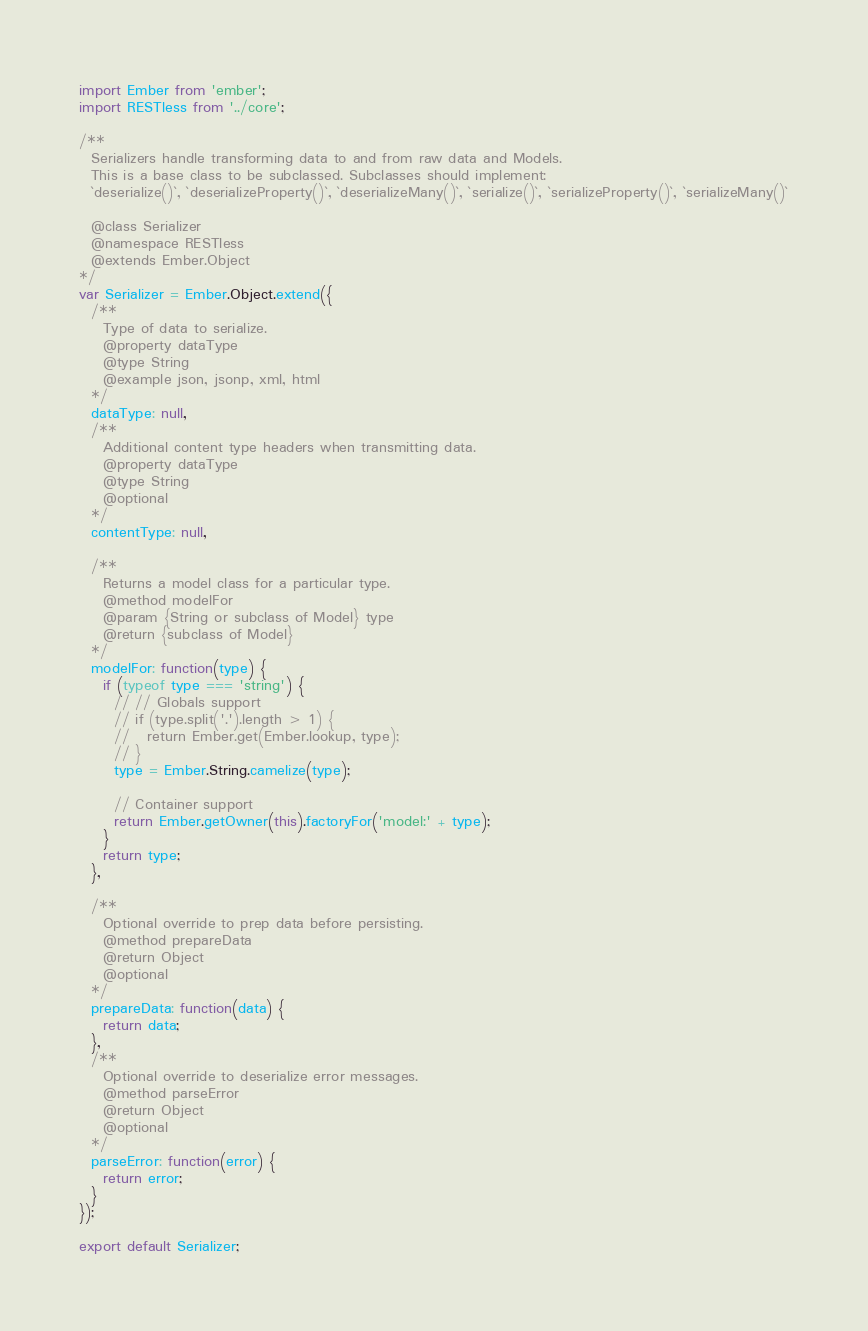Convert code to text. <code><loc_0><loc_0><loc_500><loc_500><_JavaScript_>import Ember from 'ember';
import RESTless from '../core';

/**
  Serializers handle transforming data to and from raw data and Models.
  This is a base class to be subclassed. Subclasses should implement:
  `deserialize()`, `deserializeProperty()`, `deserializeMany()`, `serialize()`, `serializeProperty()`, `serializeMany()`

  @class Serializer
  @namespace RESTless
  @extends Ember.Object
*/
var Serializer = Ember.Object.extend({
  /**
    Type of data to serialize.
    @property dataType
    @type String
    @example json, jsonp, xml, html
  */
  dataType: null,
  /**
    Additional content type headers when transmitting data.
    @property dataType
    @type String
    @optional
  */
  contentType: null,

  /**
    Returns a model class for a particular type.
    @method modelFor
    @param {String or subclass of Model} type
    @return {subclass of Model}
  */
  modelFor: function(type) {
    if (typeof type === 'string') {
      // // Globals support
      // if (type.split('.').length > 1) {
      //   return Ember.get(Ember.lookup, type);
      // }
      type = Ember.String.camelize(type);

      // Container support
      return Ember.getOwner(this).factoryFor('model:' + type);
    }
    return type;
  },

  /**
    Optional override to prep data before persisting.
    @method prepareData
    @return Object
    @optional
  */
  prepareData: function(data) {
    return data;
  },
  /**
    Optional override to deserialize error messages.
    @method parseError
    @return Object
    @optional
  */
  parseError: function(error) {
    return error;
  }
});

export default Serializer;
</code> 